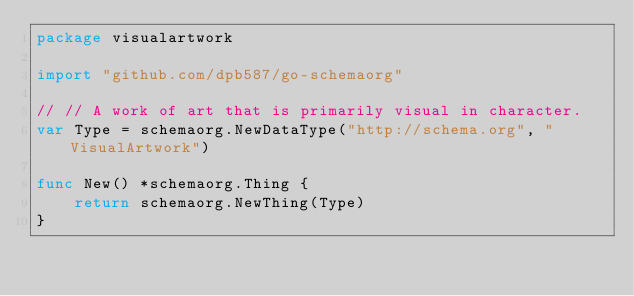Convert code to text. <code><loc_0><loc_0><loc_500><loc_500><_Go_>package visualartwork

import "github.com/dpb587/go-schemaorg"

// // A work of art that is primarily visual in character.
var Type = schemaorg.NewDataType("http://schema.org", "VisualArtwork")

func New() *schemaorg.Thing {
	return schemaorg.NewThing(Type)
}
</code> 